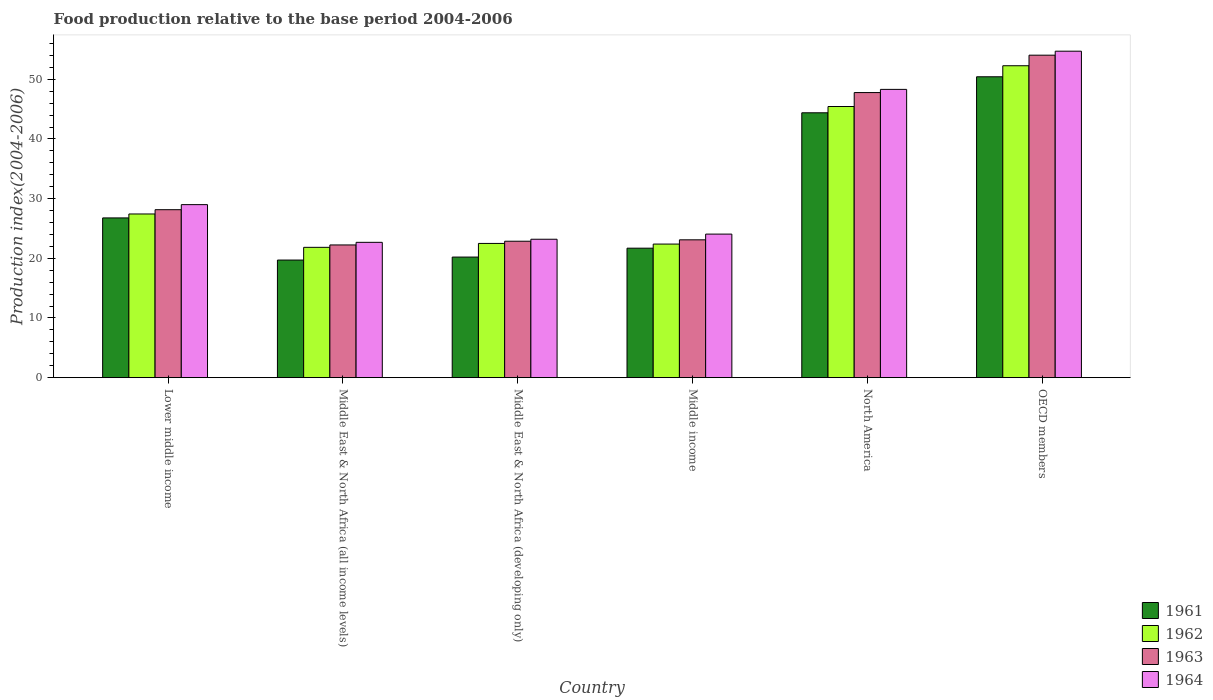How many different coloured bars are there?
Your answer should be very brief. 4. How many groups of bars are there?
Your response must be concise. 6. Are the number of bars per tick equal to the number of legend labels?
Your answer should be compact. Yes. How many bars are there on the 3rd tick from the left?
Your response must be concise. 4. What is the label of the 4th group of bars from the left?
Keep it short and to the point. Middle income. In how many cases, is the number of bars for a given country not equal to the number of legend labels?
Offer a very short reply. 0. What is the food production index in 1964 in Lower middle income?
Offer a terse response. 29. Across all countries, what is the maximum food production index in 1963?
Ensure brevity in your answer.  54.04. Across all countries, what is the minimum food production index in 1964?
Give a very brief answer. 22.68. In which country was the food production index in 1962 minimum?
Give a very brief answer. Middle East & North Africa (all income levels). What is the total food production index in 1963 in the graph?
Offer a very short reply. 198.17. What is the difference between the food production index in 1964 in Middle East & North Africa (developing only) and that in North America?
Offer a terse response. -25.12. What is the difference between the food production index in 1961 in Lower middle income and the food production index in 1962 in Middle East & North Africa (developing only)?
Offer a terse response. 4.27. What is the average food production index in 1964 per country?
Offer a very short reply. 33.66. What is the difference between the food production index of/in 1961 and food production index of/in 1963 in Middle East & North Africa (all income levels)?
Offer a very short reply. -2.53. What is the ratio of the food production index in 1963 in Lower middle income to that in Middle East & North Africa (all income levels)?
Keep it short and to the point. 1.27. Is the food production index in 1961 in North America less than that in OECD members?
Offer a very short reply. Yes. What is the difference between the highest and the second highest food production index in 1961?
Your answer should be compact. 23.65. What is the difference between the highest and the lowest food production index in 1963?
Your answer should be compact. 31.8. In how many countries, is the food production index in 1963 greater than the average food production index in 1963 taken over all countries?
Keep it short and to the point. 2. Is the sum of the food production index in 1963 in Middle East & North Africa (all income levels) and OECD members greater than the maximum food production index in 1961 across all countries?
Provide a short and direct response. Yes. Is it the case that in every country, the sum of the food production index in 1963 and food production index in 1964 is greater than the sum of food production index in 1962 and food production index in 1961?
Offer a terse response. No. What does the 2nd bar from the left in Middle East & North Africa (developing only) represents?
Keep it short and to the point. 1962. Is it the case that in every country, the sum of the food production index in 1963 and food production index in 1961 is greater than the food production index in 1964?
Ensure brevity in your answer.  Yes. How many countries are there in the graph?
Ensure brevity in your answer.  6. How are the legend labels stacked?
Make the answer very short. Vertical. What is the title of the graph?
Offer a very short reply. Food production relative to the base period 2004-2006. Does "1963" appear as one of the legend labels in the graph?
Provide a short and direct response. Yes. What is the label or title of the Y-axis?
Your response must be concise. Production index(2004-2006). What is the Production index(2004-2006) of 1961 in Lower middle income?
Your answer should be very brief. 26.77. What is the Production index(2004-2006) in 1962 in Lower middle income?
Offer a terse response. 27.43. What is the Production index(2004-2006) of 1963 in Lower middle income?
Offer a terse response. 28.15. What is the Production index(2004-2006) of 1964 in Lower middle income?
Ensure brevity in your answer.  29. What is the Production index(2004-2006) of 1961 in Middle East & North Africa (all income levels)?
Ensure brevity in your answer.  19.71. What is the Production index(2004-2006) in 1962 in Middle East & North Africa (all income levels)?
Make the answer very short. 21.84. What is the Production index(2004-2006) in 1963 in Middle East & North Africa (all income levels)?
Offer a very short reply. 22.24. What is the Production index(2004-2006) of 1964 in Middle East & North Africa (all income levels)?
Keep it short and to the point. 22.68. What is the Production index(2004-2006) in 1961 in Middle East & North Africa (developing only)?
Your answer should be compact. 20.21. What is the Production index(2004-2006) of 1962 in Middle East & North Africa (developing only)?
Your answer should be very brief. 22.5. What is the Production index(2004-2006) in 1963 in Middle East & North Africa (developing only)?
Provide a succinct answer. 22.86. What is the Production index(2004-2006) of 1964 in Middle East & North Africa (developing only)?
Your response must be concise. 23.2. What is the Production index(2004-2006) in 1961 in Middle income?
Your answer should be compact. 21.7. What is the Production index(2004-2006) in 1962 in Middle income?
Give a very brief answer. 22.39. What is the Production index(2004-2006) of 1963 in Middle income?
Your answer should be very brief. 23.1. What is the Production index(2004-2006) of 1964 in Middle income?
Your answer should be very brief. 24.06. What is the Production index(2004-2006) of 1961 in North America?
Your answer should be compact. 44.39. What is the Production index(2004-2006) of 1962 in North America?
Provide a succinct answer. 45.44. What is the Production index(2004-2006) in 1963 in North America?
Keep it short and to the point. 47.78. What is the Production index(2004-2006) of 1964 in North America?
Provide a succinct answer. 48.31. What is the Production index(2004-2006) in 1961 in OECD members?
Keep it short and to the point. 50.42. What is the Production index(2004-2006) in 1962 in OECD members?
Offer a terse response. 52.27. What is the Production index(2004-2006) in 1963 in OECD members?
Ensure brevity in your answer.  54.04. What is the Production index(2004-2006) of 1964 in OECD members?
Offer a terse response. 54.71. Across all countries, what is the maximum Production index(2004-2006) of 1961?
Keep it short and to the point. 50.42. Across all countries, what is the maximum Production index(2004-2006) in 1962?
Ensure brevity in your answer.  52.27. Across all countries, what is the maximum Production index(2004-2006) of 1963?
Ensure brevity in your answer.  54.04. Across all countries, what is the maximum Production index(2004-2006) of 1964?
Your answer should be very brief. 54.71. Across all countries, what is the minimum Production index(2004-2006) of 1961?
Provide a succinct answer. 19.71. Across all countries, what is the minimum Production index(2004-2006) in 1962?
Give a very brief answer. 21.84. Across all countries, what is the minimum Production index(2004-2006) in 1963?
Offer a very short reply. 22.24. Across all countries, what is the minimum Production index(2004-2006) in 1964?
Keep it short and to the point. 22.68. What is the total Production index(2004-2006) of 1961 in the graph?
Your answer should be very brief. 183.2. What is the total Production index(2004-2006) in 1962 in the graph?
Your answer should be very brief. 191.87. What is the total Production index(2004-2006) in 1963 in the graph?
Keep it short and to the point. 198.17. What is the total Production index(2004-2006) of 1964 in the graph?
Keep it short and to the point. 201.95. What is the difference between the Production index(2004-2006) in 1961 in Lower middle income and that in Middle East & North Africa (all income levels)?
Your response must be concise. 7.06. What is the difference between the Production index(2004-2006) in 1962 in Lower middle income and that in Middle East & North Africa (all income levels)?
Your answer should be very brief. 5.59. What is the difference between the Production index(2004-2006) in 1963 in Lower middle income and that in Middle East & North Africa (all income levels)?
Keep it short and to the point. 5.91. What is the difference between the Production index(2004-2006) of 1964 in Lower middle income and that in Middle East & North Africa (all income levels)?
Provide a short and direct response. 6.32. What is the difference between the Production index(2004-2006) in 1961 in Lower middle income and that in Middle East & North Africa (developing only)?
Provide a succinct answer. 6.56. What is the difference between the Production index(2004-2006) of 1962 in Lower middle income and that in Middle East & North Africa (developing only)?
Ensure brevity in your answer.  4.93. What is the difference between the Production index(2004-2006) in 1963 in Lower middle income and that in Middle East & North Africa (developing only)?
Offer a very short reply. 5.28. What is the difference between the Production index(2004-2006) in 1964 in Lower middle income and that in Middle East & North Africa (developing only)?
Provide a short and direct response. 5.8. What is the difference between the Production index(2004-2006) in 1961 in Lower middle income and that in Middle income?
Offer a very short reply. 5.07. What is the difference between the Production index(2004-2006) in 1962 in Lower middle income and that in Middle income?
Keep it short and to the point. 5.04. What is the difference between the Production index(2004-2006) in 1963 in Lower middle income and that in Middle income?
Give a very brief answer. 5.05. What is the difference between the Production index(2004-2006) in 1964 in Lower middle income and that in Middle income?
Offer a very short reply. 4.94. What is the difference between the Production index(2004-2006) in 1961 in Lower middle income and that in North America?
Make the answer very short. -17.62. What is the difference between the Production index(2004-2006) in 1962 in Lower middle income and that in North America?
Keep it short and to the point. -18.01. What is the difference between the Production index(2004-2006) in 1963 in Lower middle income and that in North America?
Offer a very short reply. -19.63. What is the difference between the Production index(2004-2006) in 1964 in Lower middle income and that in North America?
Your response must be concise. -19.31. What is the difference between the Production index(2004-2006) in 1961 in Lower middle income and that in OECD members?
Ensure brevity in your answer.  -23.65. What is the difference between the Production index(2004-2006) in 1962 in Lower middle income and that in OECD members?
Provide a short and direct response. -24.84. What is the difference between the Production index(2004-2006) in 1963 in Lower middle income and that in OECD members?
Your answer should be compact. -25.89. What is the difference between the Production index(2004-2006) of 1964 in Lower middle income and that in OECD members?
Offer a terse response. -25.71. What is the difference between the Production index(2004-2006) in 1961 in Middle East & North Africa (all income levels) and that in Middle East & North Africa (developing only)?
Make the answer very short. -0.5. What is the difference between the Production index(2004-2006) in 1962 in Middle East & North Africa (all income levels) and that in Middle East & North Africa (developing only)?
Provide a succinct answer. -0.66. What is the difference between the Production index(2004-2006) of 1963 in Middle East & North Africa (all income levels) and that in Middle East & North Africa (developing only)?
Your answer should be compact. -0.62. What is the difference between the Production index(2004-2006) of 1964 in Middle East & North Africa (all income levels) and that in Middle East & North Africa (developing only)?
Make the answer very short. -0.52. What is the difference between the Production index(2004-2006) of 1961 in Middle East & North Africa (all income levels) and that in Middle income?
Give a very brief answer. -1.99. What is the difference between the Production index(2004-2006) of 1962 in Middle East & North Africa (all income levels) and that in Middle income?
Keep it short and to the point. -0.55. What is the difference between the Production index(2004-2006) in 1963 in Middle East & North Africa (all income levels) and that in Middle income?
Provide a short and direct response. -0.86. What is the difference between the Production index(2004-2006) of 1964 in Middle East & North Africa (all income levels) and that in Middle income?
Provide a short and direct response. -1.38. What is the difference between the Production index(2004-2006) of 1961 in Middle East & North Africa (all income levels) and that in North America?
Provide a succinct answer. -24.68. What is the difference between the Production index(2004-2006) of 1962 in Middle East & North Africa (all income levels) and that in North America?
Keep it short and to the point. -23.6. What is the difference between the Production index(2004-2006) of 1963 in Middle East & North Africa (all income levels) and that in North America?
Give a very brief answer. -25.54. What is the difference between the Production index(2004-2006) in 1964 in Middle East & North Africa (all income levels) and that in North America?
Give a very brief answer. -25.63. What is the difference between the Production index(2004-2006) of 1961 in Middle East & North Africa (all income levels) and that in OECD members?
Ensure brevity in your answer.  -30.71. What is the difference between the Production index(2004-2006) of 1962 in Middle East & North Africa (all income levels) and that in OECD members?
Make the answer very short. -30.43. What is the difference between the Production index(2004-2006) in 1963 in Middle East & North Africa (all income levels) and that in OECD members?
Ensure brevity in your answer.  -31.8. What is the difference between the Production index(2004-2006) of 1964 in Middle East & North Africa (all income levels) and that in OECD members?
Offer a terse response. -32.03. What is the difference between the Production index(2004-2006) of 1961 in Middle East & North Africa (developing only) and that in Middle income?
Make the answer very short. -1.49. What is the difference between the Production index(2004-2006) of 1962 in Middle East & North Africa (developing only) and that in Middle income?
Your response must be concise. 0.11. What is the difference between the Production index(2004-2006) in 1963 in Middle East & North Africa (developing only) and that in Middle income?
Ensure brevity in your answer.  -0.24. What is the difference between the Production index(2004-2006) in 1964 in Middle East & North Africa (developing only) and that in Middle income?
Keep it short and to the point. -0.86. What is the difference between the Production index(2004-2006) of 1961 in Middle East & North Africa (developing only) and that in North America?
Make the answer very short. -24.18. What is the difference between the Production index(2004-2006) in 1962 in Middle East & North Africa (developing only) and that in North America?
Provide a succinct answer. -22.94. What is the difference between the Production index(2004-2006) of 1963 in Middle East & North Africa (developing only) and that in North America?
Make the answer very short. -24.91. What is the difference between the Production index(2004-2006) in 1964 in Middle East & North Africa (developing only) and that in North America?
Your answer should be very brief. -25.12. What is the difference between the Production index(2004-2006) in 1961 in Middle East & North Africa (developing only) and that in OECD members?
Make the answer very short. -30.21. What is the difference between the Production index(2004-2006) of 1962 in Middle East & North Africa (developing only) and that in OECD members?
Provide a short and direct response. -29.78. What is the difference between the Production index(2004-2006) in 1963 in Middle East & North Africa (developing only) and that in OECD members?
Offer a terse response. -31.18. What is the difference between the Production index(2004-2006) in 1964 in Middle East & North Africa (developing only) and that in OECD members?
Your answer should be compact. -31.51. What is the difference between the Production index(2004-2006) of 1961 in Middle income and that in North America?
Offer a very short reply. -22.69. What is the difference between the Production index(2004-2006) in 1962 in Middle income and that in North America?
Provide a short and direct response. -23.05. What is the difference between the Production index(2004-2006) in 1963 in Middle income and that in North America?
Your response must be concise. -24.68. What is the difference between the Production index(2004-2006) in 1964 in Middle income and that in North America?
Ensure brevity in your answer.  -24.25. What is the difference between the Production index(2004-2006) in 1961 in Middle income and that in OECD members?
Make the answer very short. -28.72. What is the difference between the Production index(2004-2006) of 1962 in Middle income and that in OECD members?
Give a very brief answer. -29.88. What is the difference between the Production index(2004-2006) of 1963 in Middle income and that in OECD members?
Offer a terse response. -30.94. What is the difference between the Production index(2004-2006) in 1964 in Middle income and that in OECD members?
Your response must be concise. -30.65. What is the difference between the Production index(2004-2006) in 1961 in North America and that in OECD members?
Provide a succinct answer. -6.03. What is the difference between the Production index(2004-2006) of 1962 in North America and that in OECD members?
Make the answer very short. -6.83. What is the difference between the Production index(2004-2006) in 1963 in North America and that in OECD members?
Provide a succinct answer. -6.27. What is the difference between the Production index(2004-2006) in 1964 in North America and that in OECD members?
Offer a very short reply. -6.4. What is the difference between the Production index(2004-2006) in 1961 in Lower middle income and the Production index(2004-2006) in 1962 in Middle East & North Africa (all income levels)?
Offer a terse response. 4.93. What is the difference between the Production index(2004-2006) of 1961 in Lower middle income and the Production index(2004-2006) of 1963 in Middle East & North Africa (all income levels)?
Make the answer very short. 4.53. What is the difference between the Production index(2004-2006) in 1961 in Lower middle income and the Production index(2004-2006) in 1964 in Middle East & North Africa (all income levels)?
Offer a very short reply. 4.09. What is the difference between the Production index(2004-2006) in 1962 in Lower middle income and the Production index(2004-2006) in 1963 in Middle East & North Africa (all income levels)?
Offer a terse response. 5.19. What is the difference between the Production index(2004-2006) of 1962 in Lower middle income and the Production index(2004-2006) of 1964 in Middle East & North Africa (all income levels)?
Ensure brevity in your answer.  4.75. What is the difference between the Production index(2004-2006) in 1963 in Lower middle income and the Production index(2004-2006) in 1964 in Middle East & North Africa (all income levels)?
Offer a very short reply. 5.47. What is the difference between the Production index(2004-2006) in 1961 in Lower middle income and the Production index(2004-2006) in 1962 in Middle East & North Africa (developing only)?
Offer a terse response. 4.27. What is the difference between the Production index(2004-2006) of 1961 in Lower middle income and the Production index(2004-2006) of 1963 in Middle East & North Africa (developing only)?
Keep it short and to the point. 3.91. What is the difference between the Production index(2004-2006) of 1961 in Lower middle income and the Production index(2004-2006) of 1964 in Middle East & North Africa (developing only)?
Offer a terse response. 3.57. What is the difference between the Production index(2004-2006) of 1962 in Lower middle income and the Production index(2004-2006) of 1963 in Middle East & North Africa (developing only)?
Give a very brief answer. 4.57. What is the difference between the Production index(2004-2006) in 1962 in Lower middle income and the Production index(2004-2006) in 1964 in Middle East & North Africa (developing only)?
Keep it short and to the point. 4.23. What is the difference between the Production index(2004-2006) of 1963 in Lower middle income and the Production index(2004-2006) of 1964 in Middle East & North Africa (developing only)?
Provide a succinct answer. 4.95. What is the difference between the Production index(2004-2006) of 1961 in Lower middle income and the Production index(2004-2006) of 1962 in Middle income?
Give a very brief answer. 4.38. What is the difference between the Production index(2004-2006) of 1961 in Lower middle income and the Production index(2004-2006) of 1963 in Middle income?
Your answer should be compact. 3.67. What is the difference between the Production index(2004-2006) of 1961 in Lower middle income and the Production index(2004-2006) of 1964 in Middle income?
Your answer should be compact. 2.71. What is the difference between the Production index(2004-2006) in 1962 in Lower middle income and the Production index(2004-2006) in 1963 in Middle income?
Make the answer very short. 4.33. What is the difference between the Production index(2004-2006) of 1962 in Lower middle income and the Production index(2004-2006) of 1964 in Middle income?
Your answer should be very brief. 3.37. What is the difference between the Production index(2004-2006) in 1963 in Lower middle income and the Production index(2004-2006) in 1964 in Middle income?
Give a very brief answer. 4.09. What is the difference between the Production index(2004-2006) of 1961 in Lower middle income and the Production index(2004-2006) of 1962 in North America?
Offer a terse response. -18.67. What is the difference between the Production index(2004-2006) of 1961 in Lower middle income and the Production index(2004-2006) of 1963 in North America?
Your response must be concise. -21.01. What is the difference between the Production index(2004-2006) in 1961 in Lower middle income and the Production index(2004-2006) in 1964 in North America?
Make the answer very short. -21.54. What is the difference between the Production index(2004-2006) of 1962 in Lower middle income and the Production index(2004-2006) of 1963 in North America?
Your response must be concise. -20.35. What is the difference between the Production index(2004-2006) in 1962 in Lower middle income and the Production index(2004-2006) in 1964 in North America?
Provide a short and direct response. -20.88. What is the difference between the Production index(2004-2006) of 1963 in Lower middle income and the Production index(2004-2006) of 1964 in North America?
Provide a succinct answer. -20.16. What is the difference between the Production index(2004-2006) of 1961 in Lower middle income and the Production index(2004-2006) of 1962 in OECD members?
Your response must be concise. -25.5. What is the difference between the Production index(2004-2006) of 1961 in Lower middle income and the Production index(2004-2006) of 1963 in OECD members?
Provide a short and direct response. -27.27. What is the difference between the Production index(2004-2006) in 1961 in Lower middle income and the Production index(2004-2006) in 1964 in OECD members?
Make the answer very short. -27.94. What is the difference between the Production index(2004-2006) of 1962 in Lower middle income and the Production index(2004-2006) of 1963 in OECD members?
Provide a short and direct response. -26.61. What is the difference between the Production index(2004-2006) in 1962 in Lower middle income and the Production index(2004-2006) in 1964 in OECD members?
Your answer should be compact. -27.28. What is the difference between the Production index(2004-2006) of 1963 in Lower middle income and the Production index(2004-2006) of 1964 in OECD members?
Keep it short and to the point. -26.56. What is the difference between the Production index(2004-2006) of 1961 in Middle East & North Africa (all income levels) and the Production index(2004-2006) of 1962 in Middle East & North Africa (developing only)?
Offer a very short reply. -2.79. What is the difference between the Production index(2004-2006) of 1961 in Middle East & North Africa (all income levels) and the Production index(2004-2006) of 1963 in Middle East & North Africa (developing only)?
Offer a very short reply. -3.15. What is the difference between the Production index(2004-2006) of 1961 in Middle East & North Africa (all income levels) and the Production index(2004-2006) of 1964 in Middle East & North Africa (developing only)?
Your response must be concise. -3.49. What is the difference between the Production index(2004-2006) of 1962 in Middle East & North Africa (all income levels) and the Production index(2004-2006) of 1963 in Middle East & North Africa (developing only)?
Your answer should be compact. -1.02. What is the difference between the Production index(2004-2006) in 1962 in Middle East & North Africa (all income levels) and the Production index(2004-2006) in 1964 in Middle East & North Africa (developing only)?
Provide a short and direct response. -1.36. What is the difference between the Production index(2004-2006) in 1963 in Middle East & North Africa (all income levels) and the Production index(2004-2006) in 1964 in Middle East & North Africa (developing only)?
Provide a succinct answer. -0.96. What is the difference between the Production index(2004-2006) in 1961 in Middle East & North Africa (all income levels) and the Production index(2004-2006) in 1962 in Middle income?
Your response must be concise. -2.68. What is the difference between the Production index(2004-2006) in 1961 in Middle East & North Africa (all income levels) and the Production index(2004-2006) in 1963 in Middle income?
Offer a terse response. -3.39. What is the difference between the Production index(2004-2006) of 1961 in Middle East & North Africa (all income levels) and the Production index(2004-2006) of 1964 in Middle income?
Your answer should be very brief. -4.35. What is the difference between the Production index(2004-2006) in 1962 in Middle East & North Africa (all income levels) and the Production index(2004-2006) in 1963 in Middle income?
Make the answer very short. -1.26. What is the difference between the Production index(2004-2006) of 1962 in Middle East & North Africa (all income levels) and the Production index(2004-2006) of 1964 in Middle income?
Make the answer very short. -2.22. What is the difference between the Production index(2004-2006) of 1963 in Middle East & North Africa (all income levels) and the Production index(2004-2006) of 1964 in Middle income?
Offer a terse response. -1.82. What is the difference between the Production index(2004-2006) in 1961 in Middle East & North Africa (all income levels) and the Production index(2004-2006) in 1962 in North America?
Keep it short and to the point. -25.73. What is the difference between the Production index(2004-2006) in 1961 in Middle East & North Africa (all income levels) and the Production index(2004-2006) in 1963 in North America?
Provide a short and direct response. -28.07. What is the difference between the Production index(2004-2006) in 1961 in Middle East & North Africa (all income levels) and the Production index(2004-2006) in 1964 in North America?
Keep it short and to the point. -28.6. What is the difference between the Production index(2004-2006) in 1962 in Middle East & North Africa (all income levels) and the Production index(2004-2006) in 1963 in North America?
Provide a succinct answer. -25.94. What is the difference between the Production index(2004-2006) in 1962 in Middle East & North Africa (all income levels) and the Production index(2004-2006) in 1964 in North America?
Offer a very short reply. -26.47. What is the difference between the Production index(2004-2006) in 1963 in Middle East & North Africa (all income levels) and the Production index(2004-2006) in 1964 in North America?
Keep it short and to the point. -26.07. What is the difference between the Production index(2004-2006) in 1961 in Middle East & North Africa (all income levels) and the Production index(2004-2006) in 1962 in OECD members?
Ensure brevity in your answer.  -32.56. What is the difference between the Production index(2004-2006) of 1961 in Middle East & North Africa (all income levels) and the Production index(2004-2006) of 1963 in OECD members?
Provide a succinct answer. -34.33. What is the difference between the Production index(2004-2006) in 1961 in Middle East & North Africa (all income levels) and the Production index(2004-2006) in 1964 in OECD members?
Keep it short and to the point. -35. What is the difference between the Production index(2004-2006) of 1962 in Middle East & North Africa (all income levels) and the Production index(2004-2006) of 1963 in OECD members?
Ensure brevity in your answer.  -32.2. What is the difference between the Production index(2004-2006) of 1962 in Middle East & North Africa (all income levels) and the Production index(2004-2006) of 1964 in OECD members?
Ensure brevity in your answer.  -32.87. What is the difference between the Production index(2004-2006) of 1963 in Middle East & North Africa (all income levels) and the Production index(2004-2006) of 1964 in OECD members?
Give a very brief answer. -32.47. What is the difference between the Production index(2004-2006) in 1961 in Middle East & North Africa (developing only) and the Production index(2004-2006) in 1962 in Middle income?
Your answer should be very brief. -2.18. What is the difference between the Production index(2004-2006) in 1961 in Middle East & North Africa (developing only) and the Production index(2004-2006) in 1963 in Middle income?
Offer a terse response. -2.89. What is the difference between the Production index(2004-2006) of 1961 in Middle East & North Africa (developing only) and the Production index(2004-2006) of 1964 in Middle income?
Provide a short and direct response. -3.85. What is the difference between the Production index(2004-2006) of 1962 in Middle East & North Africa (developing only) and the Production index(2004-2006) of 1963 in Middle income?
Your response must be concise. -0.6. What is the difference between the Production index(2004-2006) in 1962 in Middle East & North Africa (developing only) and the Production index(2004-2006) in 1964 in Middle income?
Your answer should be very brief. -1.56. What is the difference between the Production index(2004-2006) of 1963 in Middle East & North Africa (developing only) and the Production index(2004-2006) of 1964 in Middle income?
Keep it short and to the point. -1.2. What is the difference between the Production index(2004-2006) of 1961 in Middle East & North Africa (developing only) and the Production index(2004-2006) of 1962 in North America?
Offer a very short reply. -25.23. What is the difference between the Production index(2004-2006) of 1961 in Middle East & North Africa (developing only) and the Production index(2004-2006) of 1963 in North America?
Your response must be concise. -27.57. What is the difference between the Production index(2004-2006) of 1961 in Middle East & North Africa (developing only) and the Production index(2004-2006) of 1964 in North America?
Provide a succinct answer. -28.1. What is the difference between the Production index(2004-2006) in 1962 in Middle East & North Africa (developing only) and the Production index(2004-2006) in 1963 in North America?
Give a very brief answer. -25.28. What is the difference between the Production index(2004-2006) in 1962 in Middle East & North Africa (developing only) and the Production index(2004-2006) in 1964 in North America?
Ensure brevity in your answer.  -25.81. What is the difference between the Production index(2004-2006) in 1963 in Middle East & North Africa (developing only) and the Production index(2004-2006) in 1964 in North America?
Your response must be concise. -25.45. What is the difference between the Production index(2004-2006) in 1961 in Middle East & North Africa (developing only) and the Production index(2004-2006) in 1962 in OECD members?
Your answer should be compact. -32.06. What is the difference between the Production index(2004-2006) of 1961 in Middle East & North Africa (developing only) and the Production index(2004-2006) of 1963 in OECD members?
Keep it short and to the point. -33.83. What is the difference between the Production index(2004-2006) in 1961 in Middle East & North Africa (developing only) and the Production index(2004-2006) in 1964 in OECD members?
Provide a short and direct response. -34.5. What is the difference between the Production index(2004-2006) of 1962 in Middle East & North Africa (developing only) and the Production index(2004-2006) of 1963 in OECD members?
Keep it short and to the point. -31.55. What is the difference between the Production index(2004-2006) of 1962 in Middle East & North Africa (developing only) and the Production index(2004-2006) of 1964 in OECD members?
Offer a very short reply. -32.21. What is the difference between the Production index(2004-2006) in 1963 in Middle East & North Africa (developing only) and the Production index(2004-2006) in 1964 in OECD members?
Your response must be concise. -31.85. What is the difference between the Production index(2004-2006) in 1961 in Middle income and the Production index(2004-2006) in 1962 in North America?
Offer a very short reply. -23.74. What is the difference between the Production index(2004-2006) in 1961 in Middle income and the Production index(2004-2006) in 1963 in North America?
Your answer should be very brief. -26.08. What is the difference between the Production index(2004-2006) of 1961 in Middle income and the Production index(2004-2006) of 1964 in North America?
Give a very brief answer. -26.61. What is the difference between the Production index(2004-2006) of 1962 in Middle income and the Production index(2004-2006) of 1963 in North America?
Give a very brief answer. -25.39. What is the difference between the Production index(2004-2006) in 1962 in Middle income and the Production index(2004-2006) in 1964 in North America?
Your answer should be compact. -25.92. What is the difference between the Production index(2004-2006) of 1963 in Middle income and the Production index(2004-2006) of 1964 in North America?
Ensure brevity in your answer.  -25.21. What is the difference between the Production index(2004-2006) of 1961 in Middle income and the Production index(2004-2006) of 1962 in OECD members?
Offer a terse response. -30.58. What is the difference between the Production index(2004-2006) of 1961 in Middle income and the Production index(2004-2006) of 1963 in OECD members?
Give a very brief answer. -32.35. What is the difference between the Production index(2004-2006) in 1961 in Middle income and the Production index(2004-2006) in 1964 in OECD members?
Your answer should be compact. -33.01. What is the difference between the Production index(2004-2006) in 1962 in Middle income and the Production index(2004-2006) in 1963 in OECD members?
Offer a very short reply. -31.65. What is the difference between the Production index(2004-2006) in 1962 in Middle income and the Production index(2004-2006) in 1964 in OECD members?
Provide a succinct answer. -32.32. What is the difference between the Production index(2004-2006) of 1963 in Middle income and the Production index(2004-2006) of 1964 in OECD members?
Make the answer very short. -31.61. What is the difference between the Production index(2004-2006) in 1961 in North America and the Production index(2004-2006) in 1962 in OECD members?
Give a very brief answer. -7.88. What is the difference between the Production index(2004-2006) of 1961 in North America and the Production index(2004-2006) of 1963 in OECD members?
Your answer should be very brief. -9.65. What is the difference between the Production index(2004-2006) of 1961 in North America and the Production index(2004-2006) of 1964 in OECD members?
Keep it short and to the point. -10.32. What is the difference between the Production index(2004-2006) in 1962 in North America and the Production index(2004-2006) in 1963 in OECD members?
Provide a succinct answer. -8.6. What is the difference between the Production index(2004-2006) in 1962 in North America and the Production index(2004-2006) in 1964 in OECD members?
Make the answer very short. -9.27. What is the difference between the Production index(2004-2006) of 1963 in North America and the Production index(2004-2006) of 1964 in OECD members?
Keep it short and to the point. -6.93. What is the average Production index(2004-2006) of 1961 per country?
Provide a succinct answer. 30.53. What is the average Production index(2004-2006) of 1962 per country?
Provide a short and direct response. 31.98. What is the average Production index(2004-2006) in 1963 per country?
Ensure brevity in your answer.  33.03. What is the average Production index(2004-2006) in 1964 per country?
Ensure brevity in your answer.  33.66. What is the difference between the Production index(2004-2006) in 1961 and Production index(2004-2006) in 1962 in Lower middle income?
Offer a terse response. -0.66. What is the difference between the Production index(2004-2006) in 1961 and Production index(2004-2006) in 1963 in Lower middle income?
Offer a terse response. -1.38. What is the difference between the Production index(2004-2006) of 1961 and Production index(2004-2006) of 1964 in Lower middle income?
Give a very brief answer. -2.23. What is the difference between the Production index(2004-2006) in 1962 and Production index(2004-2006) in 1963 in Lower middle income?
Ensure brevity in your answer.  -0.72. What is the difference between the Production index(2004-2006) of 1962 and Production index(2004-2006) of 1964 in Lower middle income?
Make the answer very short. -1.57. What is the difference between the Production index(2004-2006) of 1963 and Production index(2004-2006) of 1964 in Lower middle income?
Your answer should be compact. -0.85. What is the difference between the Production index(2004-2006) of 1961 and Production index(2004-2006) of 1962 in Middle East & North Africa (all income levels)?
Keep it short and to the point. -2.13. What is the difference between the Production index(2004-2006) in 1961 and Production index(2004-2006) in 1963 in Middle East & North Africa (all income levels)?
Your answer should be compact. -2.53. What is the difference between the Production index(2004-2006) in 1961 and Production index(2004-2006) in 1964 in Middle East & North Africa (all income levels)?
Give a very brief answer. -2.97. What is the difference between the Production index(2004-2006) in 1962 and Production index(2004-2006) in 1963 in Middle East & North Africa (all income levels)?
Ensure brevity in your answer.  -0.4. What is the difference between the Production index(2004-2006) in 1962 and Production index(2004-2006) in 1964 in Middle East & North Africa (all income levels)?
Give a very brief answer. -0.84. What is the difference between the Production index(2004-2006) in 1963 and Production index(2004-2006) in 1964 in Middle East & North Africa (all income levels)?
Your response must be concise. -0.44. What is the difference between the Production index(2004-2006) in 1961 and Production index(2004-2006) in 1962 in Middle East & North Africa (developing only)?
Your answer should be very brief. -2.29. What is the difference between the Production index(2004-2006) in 1961 and Production index(2004-2006) in 1963 in Middle East & North Africa (developing only)?
Keep it short and to the point. -2.65. What is the difference between the Production index(2004-2006) of 1961 and Production index(2004-2006) of 1964 in Middle East & North Africa (developing only)?
Offer a very short reply. -2.99. What is the difference between the Production index(2004-2006) of 1962 and Production index(2004-2006) of 1963 in Middle East & North Africa (developing only)?
Provide a short and direct response. -0.37. What is the difference between the Production index(2004-2006) of 1962 and Production index(2004-2006) of 1964 in Middle East & North Africa (developing only)?
Provide a succinct answer. -0.7. What is the difference between the Production index(2004-2006) in 1963 and Production index(2004-2006) in 1964 in Middle East & North Africa (developing only)?
Make the answer very short. -0.33. What is the difference between the Production index(2004-2006) of 1961 and Production index(2004-2006) of 1962 in Middle income?
Your response must be concise. -0.69. What is the difference between the Production index(2004-2006) of 1961 and Production index(2004-2006) of 1963 in Middle income?
Make the answer very short. -1.4. What is the difference between the Production index(2004-2006) of 1961 and Production index(2004-2006) of 1964 in Middle income?
Provide a short and direct response. -2.36. What is the difference between the Production index(2004-2006) of 1962 and Production index(2004-2006) of 1963 in Middle income?
Your answer should be very brief. -0.71. What is the difference between the Production index(2004-2006) in 1962 and Production index(2004-2006) in 1964 in Middle income?
Offer a terse response. -1.67. What is the difference between the Production index(2004-2006) of 1963 and Production index(2004-2006) of 1964 in Middle income?
Ensure brevity in your answer.  -0.96. What is the difference between the Production index(2004-2006) of 1961 and Production index(2004-2006) of 1962 in North America?
Your answer should be very brief. -1.05. What is the difference between the Production index(2004-2006) of 1961 and Production index(2004-2006) of 1963 in North America?
Your response must be concise. -3.39. What is the difference between the Production index(2004-2006) in 1961 and Production index(2004-2006) in 1964 in North America?
Your response must be concise. -3.92. What is the difference between the Production index(2004-2006) in 1962 and Production index(2004-2006) in 1963 in North America?
Ensure brevity in your answer.  -2.34. What is the difference between the Production index(2004-2006) in 1962 and Production index(2004-2006) in 1964 in North America?
Give a very brief answer. -2.87. What is the difference between the Production index(2004-2006) of 1963 and Production index(2004-2006) of 1964 in North America?
Offer a very short reply. -0.53. What is the difference between the Production index(2004-2006) of 1961 and Production index(2004-2006) of 1962 in OECD members?
Ensure brevity in your answer.  -1.85. What is the difference between the Production index(2004-2006) in 1961 and Production index(2004-2006) in 1963 in OECD members?
Your answer should be very brief. -3.62. What is the difference between the Production index(2004-2006) of 1961 and Production index(2004-2006) of 1964 in OECD members?
Offer a terse response. -4.29. What is the difference between the Production index(2004-2006) of 1962 and Production index(2004-2006) of 1963 in OECD members?
Ensure brevity in your answer.  -1.77. What is the difference between the Production index(2004-2006) in 1962 and Production index(2004-2006) in 1964 in OECD members?
Your response must be concise. -2.44. What is the difference between the Production index(2004-2006) of 1963 and Production index(2004-2006) of 1964 in OECD members?
Give a very brief answer. -0.67. What is the ratio of the Production index(2004-2006) in 1961 in Lower middle income to that in Middle East & North Africa (all income levels)?
Provide a succinct answer. 1.36. What is the ratio of the Production index(2004-2006) of 1962 in Lower middle income to that in Middle East & North Africa (all income levels)?
Offer a very short reply. 1.26. What is the ratio of the Production index(2004-2006) in 1963 in Lower middle income to that in Middle East & North Africa (all income levels)?
Offer a very short reply. 1.27. What is the ratio of the Production index(2004-2006) of 1964 in Lower middle income to that in Middle East & North Africa (all income levels)?
Offer a terse response. 1.28. What is the ratio of the Production index(2004-2006) of 1961 in Lower middle income to that in Middle East & North Africa (developing only)?
Ensure brevity in your answer.  1.32. What is the ratio of the Production index(2004-2006) in 1962 in Lower middle income to that in Middle East & North Africa (developing only)?
Your answer should be compact. 1.22. What is the ratio of the Production index(2004-2006) of 1963 in Lower middle income to that in Middle East & North Africa (developing only)?
Provide a succinct answer. 1.23. What is the ratio of the Production index(2004-2006) of 1964 in Lower middle income to that in Middle East & North Africa (developing only)?
Keep it short and to the point. 1.25. What is the ratio of the Production index(2004-2006) in 1961 in Lower middle income to that in Middle income?
Ensure brevity in your answer.  1.23. What is the ratio of the Production index(2004-2006) of 1962 in Lower middle income to that in Middle income?
Provide a short and direct response. 1.23. What is the ratio of the Production index(2004-2006) in 1963 in Lower middle income to that in Middle income?
Provide a succinct answer. 1.22. What is the ratio of the Production index(2004-2006) in 1964 in Lower middle income to that in Middle income?
Give a very brief answer. 1.21. What is the ratio of the Production index(2004-2006) of 1961 in Lower middle income to that in North America?
Offer a very short reply. 0.6. What is the ratio of the Production index(2004-2006) in 1962 in Lower middle income to that in North America?
Make the answer very short. 0.6. What is the ratio of the Production index(2004-2006) in 1963 in Lower middle income to that in North America?
Make the answer very short. 0.59. What is the ratio of the Production index(2004-2006) of 1964 in Lower middle income to that in North America?
Your answer should be very brief. 0.6. What is the ratio of the Production index(2004-2006) of 1961 in Lower middle income to that in OECD members?
Give a very brief answer. 0.53. What is the ratio of the Production index(2004-2006) in 1962 in Lower middle income to that in OECD members?
Keep it short and to the point. 0.52. What is the ratio of the Production index(2004-2006) in 1963 in Lower middle income to that in OECD members?
Your answer should be compact. 0.52. What is the ratio of the Production index(2004-2006) of 1964 in Lower middle income to that in OECD members?
Your response must be concise. 0.53. What is the ratio of the Production index(2004-2006) of 1961 in Middle East & North Africa (all income levels) to that in Middle East & North Africa (developing only)?
Ensure brevity in your answer.  0.98. What is the ratio of the Production index(2004-2006) of 1962 in Middle East & North Africa (all income levels) to that in Middle East & North Africa (developing only)?
Offer a terse response. 0.97. What is the ratio of the Production index(2004-2006) in 1963 in Middle East & North Africa (all income levels) to that in Middle East & North Africa (developing only)?
Offer a terse response. 0.97. What is the ratio of the Production index(2004-2006) in 1964 in Middle East & North Africa (all income levels) to that in Middle East & North Africa (developing only)?
Your response must be concise. 0.98. What is the ratio of the Production index(2004-2006) in 1961 in Middle East & North Africa (all income levels) to that in Middle income?
Your answer should be very brief. 0.91. What is the ratio of the Production index(2004-2006) in 1962 in Middle East & North Africa (all income levels) to that in Middle income?
Your response must be concise. 0.98. What is the ratio of the Production index(2004-2006) of 1963 in Middle East & North Africa (all income levels) to that in Middle income?
Your answer should be very brief. 0.96. What is the ratio of the Production index(2004-2006) of 1964 in Middle East & North Africa (all income levels) to that in Middle income?
Make the answer very short. 0.94. What is the ratio of the Production index(2004-2006) of 1961 in Middle East & North Africa (all income levels) to that in North America?
Offer a very short reply. 0.44. What is the ratio of the Production index(2004-2006) of 1962 in Middle East & North Africa (all income levels) to that in North America?
Offer a very short reply. 0.48. What is the ratio of the Production index(2004-2006) of 1963 in Middle East & North Africa (all income levels) to that in North America?
Make the answer very short. 0.47. What is the ratio of the Production index(2004-2006) in 1964 in Middle East & North Africa (all income levels) to that in North America?
Make the answer very short. 0.47. What is the ratio of the Production index(2004-2006) in 1961 in Middle East & North Africa (all income levels) to that in OECD members?
Keep it short and to the point. 0.39. What is the ratio of the Production index(2004-2006) in 1962 in Middle East & North Africa (all income levels) to that in OECD members?
Provide a succinct answer. 0.42. What is the ratio of the Production index(2004-2006) of 1963 in Middle East & North Africa (all income levels) to that in OECD members?
Make the answer very short. 0.41. What is the ratio of the Production index(2004-2006) of 1964 in Middle East & North Africa (all income levels) to that in OECD members?
Offer a very short reply. 0.41. What is the ratio of the Production index(2004-2006) of 1961 in Middle East & North Africa (developing only) to that in Middle income?
Offer a very short reply. 0.93. What is the ratio of the Production index(2004-2006) in 1962 in Middle East & North Africa (developing only) to that in Middle income?
Ensure brevity in your answer.  1. What is the ratio of the Production index(2004-2006) of 1963 in Middle East & North Africa (developing only) to that in Middle income?
Offer a terse response. 0.99. What is the ratio of the Production index(2004-2006) in 1964 in Middle East & North Africa (developing only) to that in Middle income?
Keep it short and to the point. 0.96. What is the ratio of the Production index(2004-2006) of 1961 in Middle East & North Africa (developing only) to that in North America?
Offer a terse response. 0.46. What is the ratio of the Production index(2004-2006) of 1962 in Middle East & North Africa (developing only) to that in North America?
Make the answer very short. 0.5. What is the ratio of the Production index(2004-2006) of 1963 in Middle East & North Africa (developing only) to that in North America?
Provide a succinct answer. 0.48. What is the ratio of the Production index(2004-2006) in 1964 in Middle East & North Africa (developing only) to that in North America?
Give a very brief answer. 0.48. What is the ratio of the Production index(2004-2006) of 1961 in Middle East & North Africa (developing only) to that in OECD members?
Offer a very short reply. 0.4. What is the ratio of the Production index(2004-2006) of 1962 in Middle East & North Africa (developing only) to that in OECD members?
Make the answer very short. 0.43. What is the ratio of the Production index(2004-2006) of 1963 in Middle East & North Africa (developing only) to that in OECD members?
Your answer should be compact. 0.42. What is the ratio of the Production index(2004-2006) of 1964 in Middle East & North Africa (developing only) to that in OECD members?
Your answer should be very brief. 0.42. What is the ratio of the Production index(2004-2006) in 1961 in Middle income to that in North America?
Your response must be concise. 0.49. What is the ratio of the Production index(2004-2006) of 1962 in Middle income to that in North America?
Give a very brief answer. 0.49. What is the ratio of the Production index(2004-2006) of 1963 in Middle income to that in North America?
Your answer should be very brief. 0.48. What is the ratio of the Production index(2004-2006) in 1964 in Middle income to that in North America?
Your response must be concise. 0.5. What is the ratio of the Production index(2004-2006) in 1961 in Middle income to that in OECD members?
Offer a very short reply. 0.43. What is the ratio of the Production index(2004-2006) in 1962 in Middle income to that in OECD members?
Give a very brief answer. 0.43. What is the ratio of the Production index(2004-2006) in 1963 in Middle income to that in OECD members?
Make the answer very short. 0.43. What is the ratio of the Production index(2004-2006) in 1964 in Middle income to that in OECD members?
Keep it short and to the point. 0.44. What is the ratio of the Production index(2004-2006) of 1961 in North America to that in OECD members?
Offer a terse response. 0.88. What is the ratio of the Production index(2004-2006) in 1962 in North America to that in OECD members?
Offer a very short reply. 0.87. What is the ratio of the Production index(2004-2006) in 1963 in North America to that in OECD members?
Your response must be concise. 0.88. What is the ratio of the Production index(2004-2006) in 1964 in North America to that in OECD members?
Ensure brevity in your answer.  0.88. What is the difference between the highest and the second highest Production index(2004-2006) of 1961?
Keep it short and to the point. 6.03. What is the difference between the highest and the second highest Production index(2004-2006) of 1962?
Your answer should be compact. 6.83. What is the difference between the highest and the second highest Production index(2004-2006) in 1963?
Offer a terse response. 6.27. What is the difference between the highest and the second highest Production index(2004-2006) of 1964?
Make the answer very short. 6.4. What is the difference between the highest and the lowest Production index(2004-2006) in 1961?
Provide a succinct answer. 30.71. What is the difference between the highest and the lowest Production index(2004-2006) of 1962?
Ensure brevity in your answer.  30.43. What is the difference between the highest and the lowest Production index(2004-2006) in 1963?
Provide a succinct answer. 31.8. What is the difference between the highest and the lowest Production index(2004-2006) of 1964?
Offer a terse response. 32.03. 